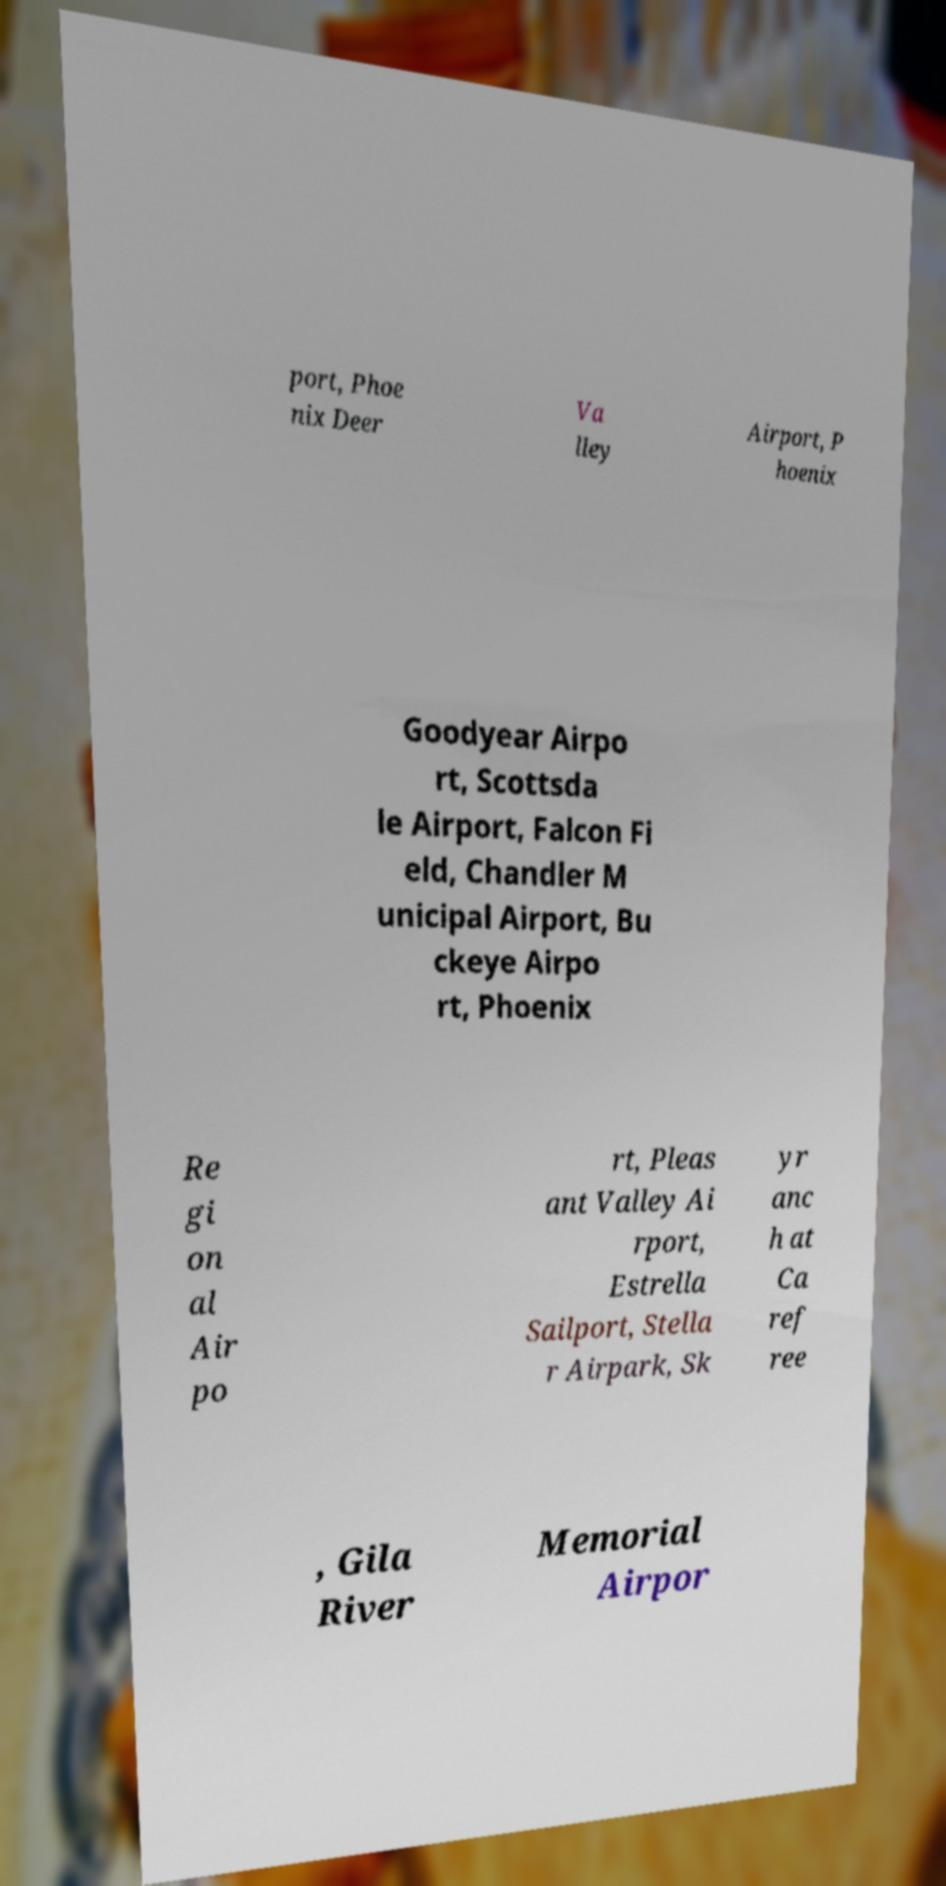Please read and relay the text visible in this image. What does it say? port, Phoe nix Deer Va lley Airport, P hoenix Goodyear Airpo rt, Scottsda le Airport, Falcon Fi eld, Chandler M unicipal Airport, Bu ckeye Airpo rt, Phoenix Re gi on al Air po rt, Pleas ant Valley Ai rport, Estrella Sailport, Stella r Airpark, Sk yr anc h at Ca ref ree , Gila River Memorial Airpor 